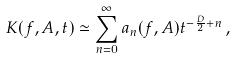Convert formula to latex. <formula><loc_0><loc_0><loc_500><loc_500>K ( f , A , t ) \simeq \sum _ { n = 0 } ^ { \infty } a _ { n } ( f , A ) t ^ { - \frac { D } { 2 } + n } \, ,</formula> 